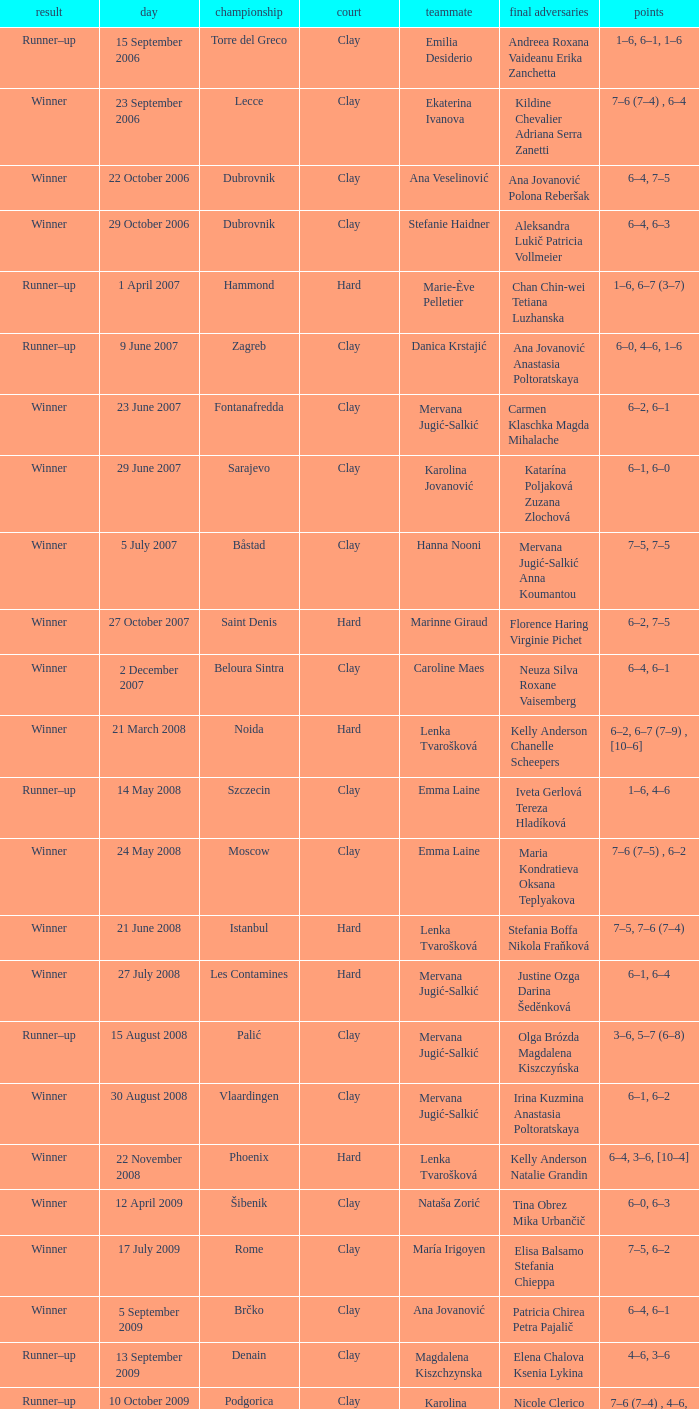Which tournament had a partner of Erika Sema? Aschaffenburg. 